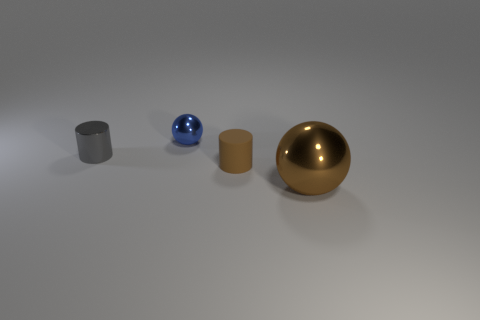Add 1 red rubber cylinders. How many objects exist? 5 Subtract 0 blue cylinders. How many objects are left? 4 Subtract all small cylinders. Subtract all shiny cylinders. How many objects are left? 1 Add 3 small shiny cylinders. How many small shiny cylinders are left? 4 Add 2 tiny blue things. How many tiny blue things exist? 3 